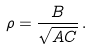Convert formula to latex. <formula><loc_0><loc_0><loc_500><loc_500>\rho = \frac { B } { \sqrt { A C } } \, .</formula> 